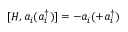Convert formula to latex. <formula><loc_0><loc_0><loc_500><loc_500>[ H , a _ { i } ( a _ { i } ^ { \dagger } ) ] = - a _ { i } ( + a _ { i } ^ { \dagger } )</formula> 